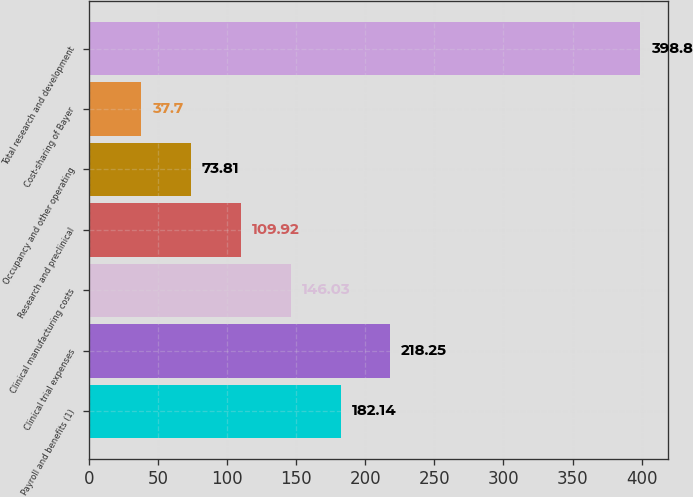Convert chart to OTSL. <chart><loc_0><loc_0><loc_500><loc_500><bar_chart><fcel>Payroll and benefits (1)<fcel>Clinical trial expenses<fcel>Clinical manufacturing costs<fcel>Research and preclinical<fcel>Occupancy and other operating<fcel>Cost-sharing of Bayer<fcel>Total research and development<nl><fcel>182.14<fcel>218.25<fcel>146.03<fcel>109.92<fcel>73.81<fcel>37.7<fcel>398.8<nl></chart> 